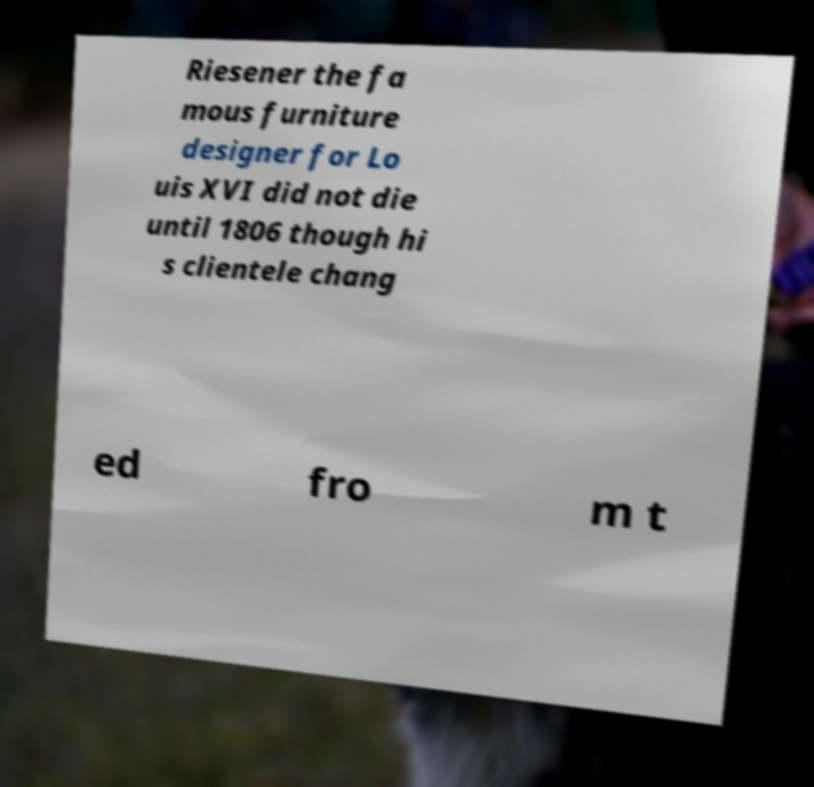Please identify and transcribe the text found in this image. Riesener the fa mous furniture designer for Lo uis XVI did not die until 1806 though hi s clientele chang ed fro m t 